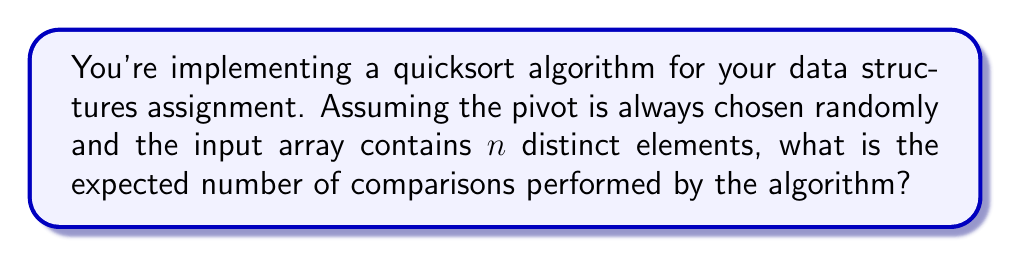Show me your answer to this math problem. Let's approach this step-by-step:

1) First, recall that quicksort works by selecting a pivot element and partitioning the array around it. This process is then recursively applied to the sub-arrays.

2) The number of comparisons in each partition step is n-1, where n is the number of elements in the current sub-array.

3) The expected number of comparisons for quicksort can be expressed recursively as:

   $$T(n) = n-1 + \frac{1}{n}\sum_{i=1}^n [T(i-1) + T(n-i)]$$

   Where T(n) is the expected number of comparisons for an array of size n.

4) This recurrence relation can be simplified to:

   $$T(n) = n-1 + \frac{2}{n}\sum_{i=1}^{n-1} T(i)$$

5) Solving this recurrence (which is beyond the scope of this explanation) leads to:

   $$T(n) = 2n\ln n + O(n)$$

6) In Big O notation, we typically omit constant factors and lower order terms. Therefore, the expected number of comparisons is O(n log n).

7) However, the question asks for the exact expected number. The precise formula is:

   $$T(n) = 2n\ln n - 2(n-1) \approx 2n\ln n - 2n + 2$$

   Where ln is the natural logarithm.
Answer: $2n\ln n - 2(n-1)$ 